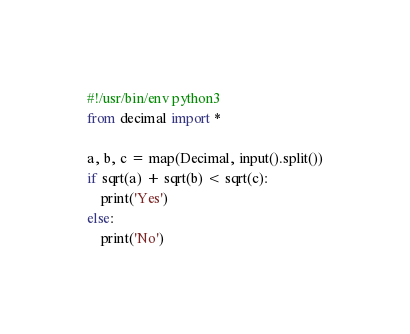Convert code to text. <code><loc_0><loc_0><loc_500><loc_500><_Python_>#!/usr/bin/env python3
from decimal import *
 
a, b, c = map(Decimal, input().split())
if sqrt(a) + sqrt(b) < sqrt(c):
    print('Yes')
else:
    print('No')</code> 